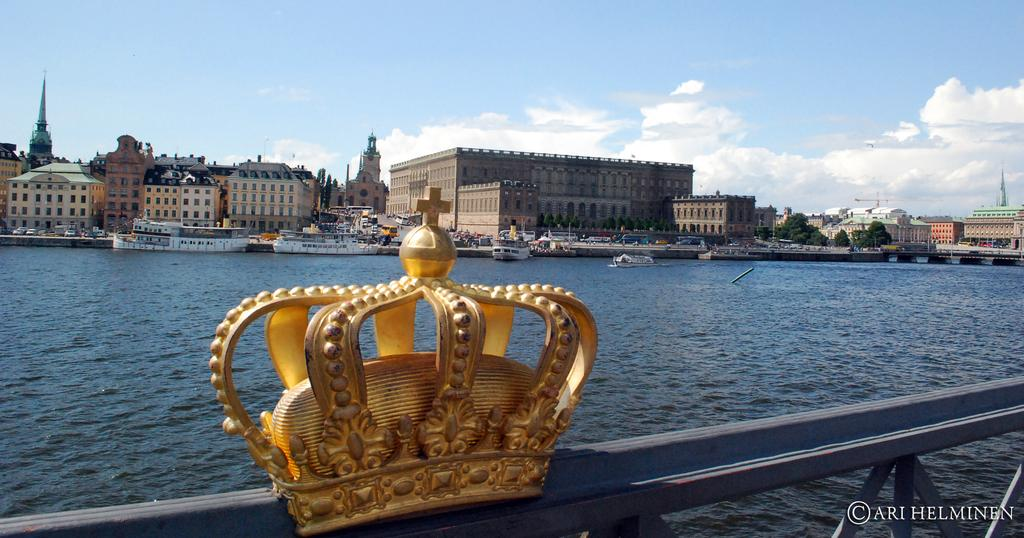What is the prominent object in the picture? There is a crown in the picture. What can be seen on the water in the picture? There are ships on the water in the picture. What type of structures are visible in the picture? There are buildings visible in the picture. What type of vegetation is present in the picture? There are trees in the picture. What is visible in the sky in the picture? Clouds are present in the sky in the picture. What type of board can be seen on the mountain in the image? There is no mountain or board present in the image. 